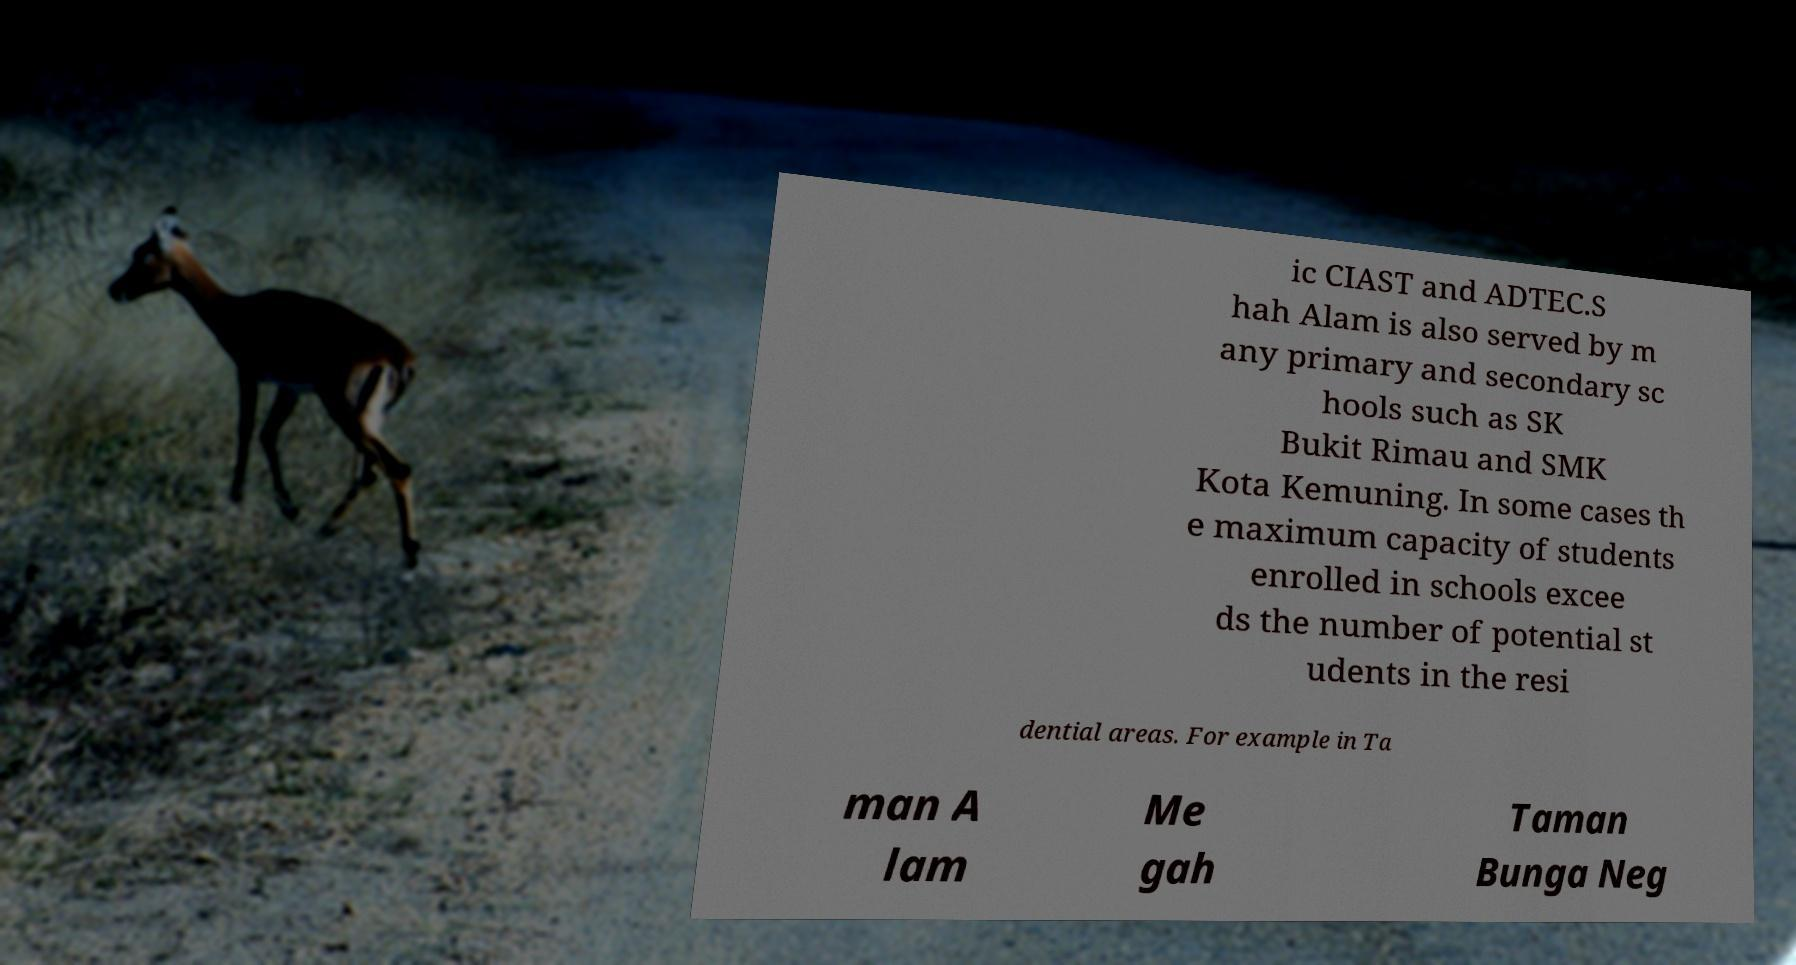What messages or text are displayed in this image? I need them in a readable, typed format. ic CIAST and ADTEC.S hah Alam is also served by m any primary and secondary sc hools such as SK Bukit Rimau and SMK Kota Kemuning. In some cases th e maximum capacity of students enrolled in schools excee ds the number of potential st udents in the resi dential areas. For example in Ta man A lam Me gah Taman Bunga Neg 